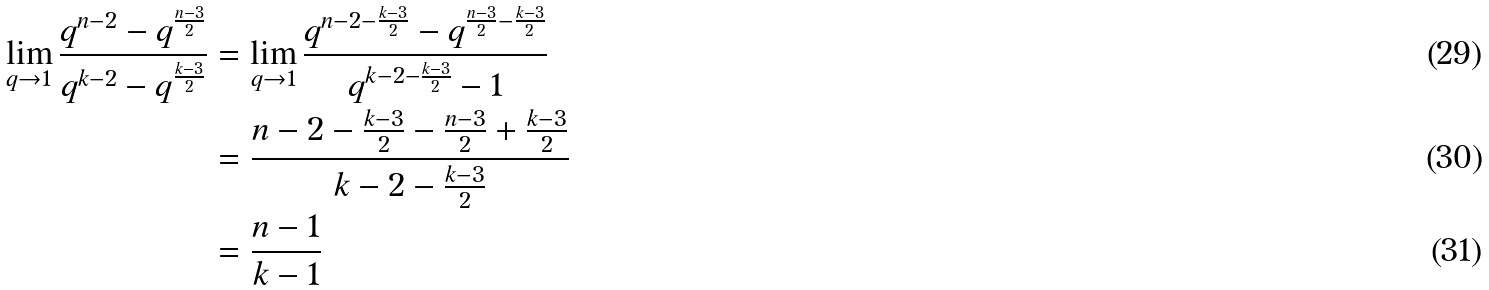Convert formula to latex. <formula><loc_0><loc_0><loc_500><loc_500>\lim _ { q \rightarrow 1 } \frac { q ^ { n - 2 } - q ^ { \frac { n - 3 } { 2 } } } { q ^ { k - 2 } - q ^ { \frac { k - 3 } { 2 } } } & = \lim _ { q \rightarrow 1 } \frac { q ^ { n - 2 - \frac { k - 3 } { 2 } } - q ^ { \frac { n - 3 } { 2 } - \frac { k - 3 } { 2 } } } { q ^ { k - 2 - \frac { k - 3 } { 2 } } - 1 } \\ & = \frac { n - 2 - \frac { k - 3 } { 2 } - \frac { n - 3 } { 2 } + \frac { k - 3 } { 2 } } { k - 2 - \frac { k - 3 } { 2 } } \\ & = \frac { n - 1 } { k - 1 }</formula> 